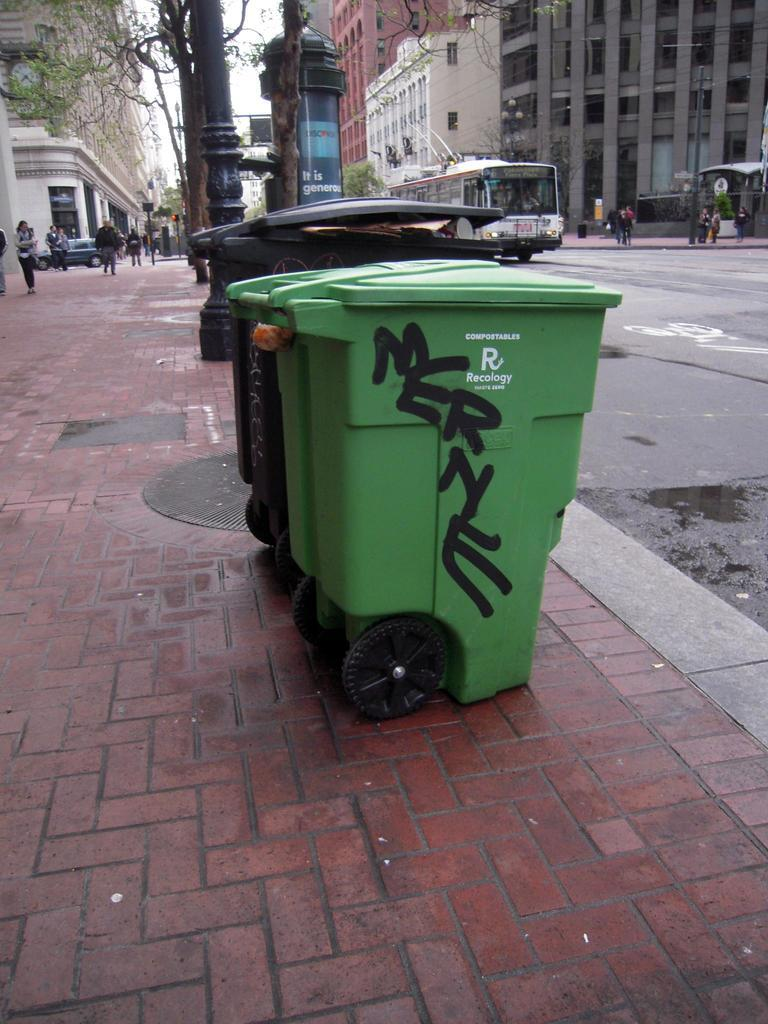<image>
Provide a brief description of the given image. The green trash can has been provided by Recology. 